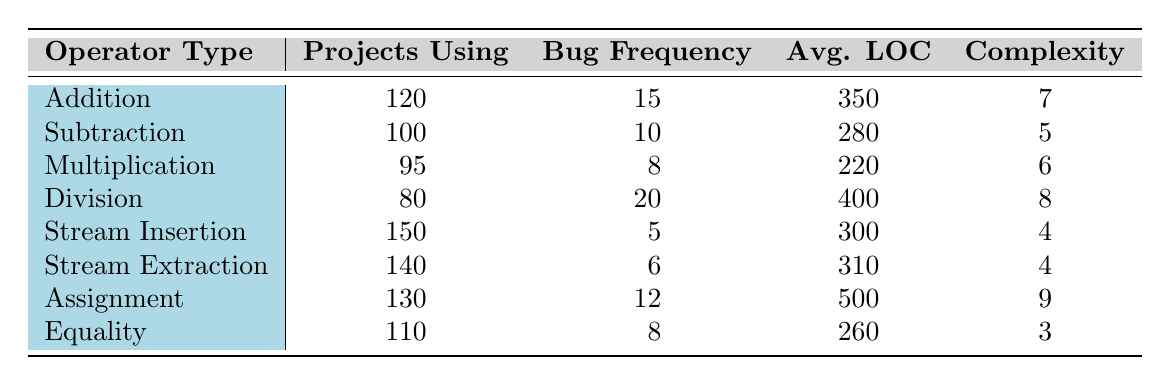What is the bug frequency associated with the Division operator? The table shows that the bug frequency for the Division operator is listed directly in the corresponding row. According to the table, it states that the bug frequency for Division is 20.
Answer: 20 Which operator type has the highest complexity score? By examining the complexity scores in the table, the Assignment operator has the highest complexity score of 9. Other operators have lower scores, thus confirming that Assignment is the highest.
Answer: Assignment How many projects use the Stream Insertion operator compared to the Stream Extraction operator? The table provides the number of projects using each operator. For Stream Insertion, there are 150 projects, while for Stream Extraction, there are 140 projects. Subtracting these gives 150 - 140 = 10, indicating that 10 more projects use Stream Insertion.
Answer: 10 What is the average lines of code for operators with bug frequencies higher than 10? From the table, the operators with a bug frequency higher than 10 are Addition (350 LOC), Division (400 LOC), and Assignment (500 LOC). Adding these up gives 350 + 400 + 500 = 1250. To find the average, divide by the number of operators (3): 1250 / 3 = 416.67.
Answer: 416.67 Is the bug frequency for Equality operator greater than that of Multiplication operator? Comparing the two values in the table, the bug frequency for Equality is 8, while for Multiplication it is 8 as well. Thus, they are equal, leading to the conclusion that the bug frequency for Equality is not greater.
Answer: No Which operator type has the lowest bug frequency and what is that frequency? The table allows for direct comparison of bug frequencies across operators. Stream Insertion has the lowest frequency at 5 bugs.
Answer: Stream Insertion, 5 